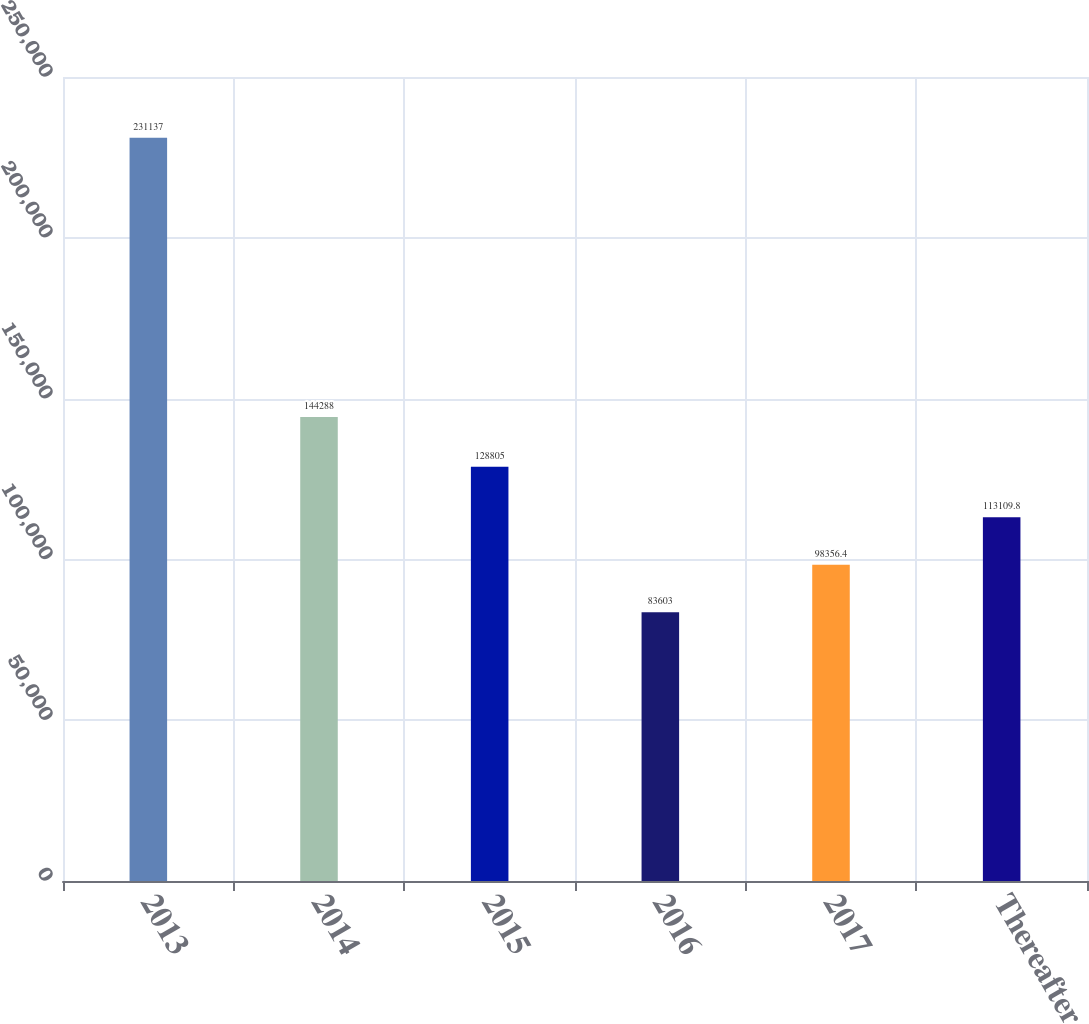Convert chart to OTSL. <chart><loc_0><loc_0><loc_500><loc_500><bar_chart><fcel>2013<fcel>2014<fcel>2015<fcel>2016<fcel>2017<fcel>Thereafter<nl><fcel>231137<fcel>144288<fcel>128805<fcel>83603<fcel>98356.4<fcel>113110<nl></chart> 